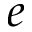Convert formula to latex. <formula><loc_0><loc_0><loc_500><loc_500>e</formula> 